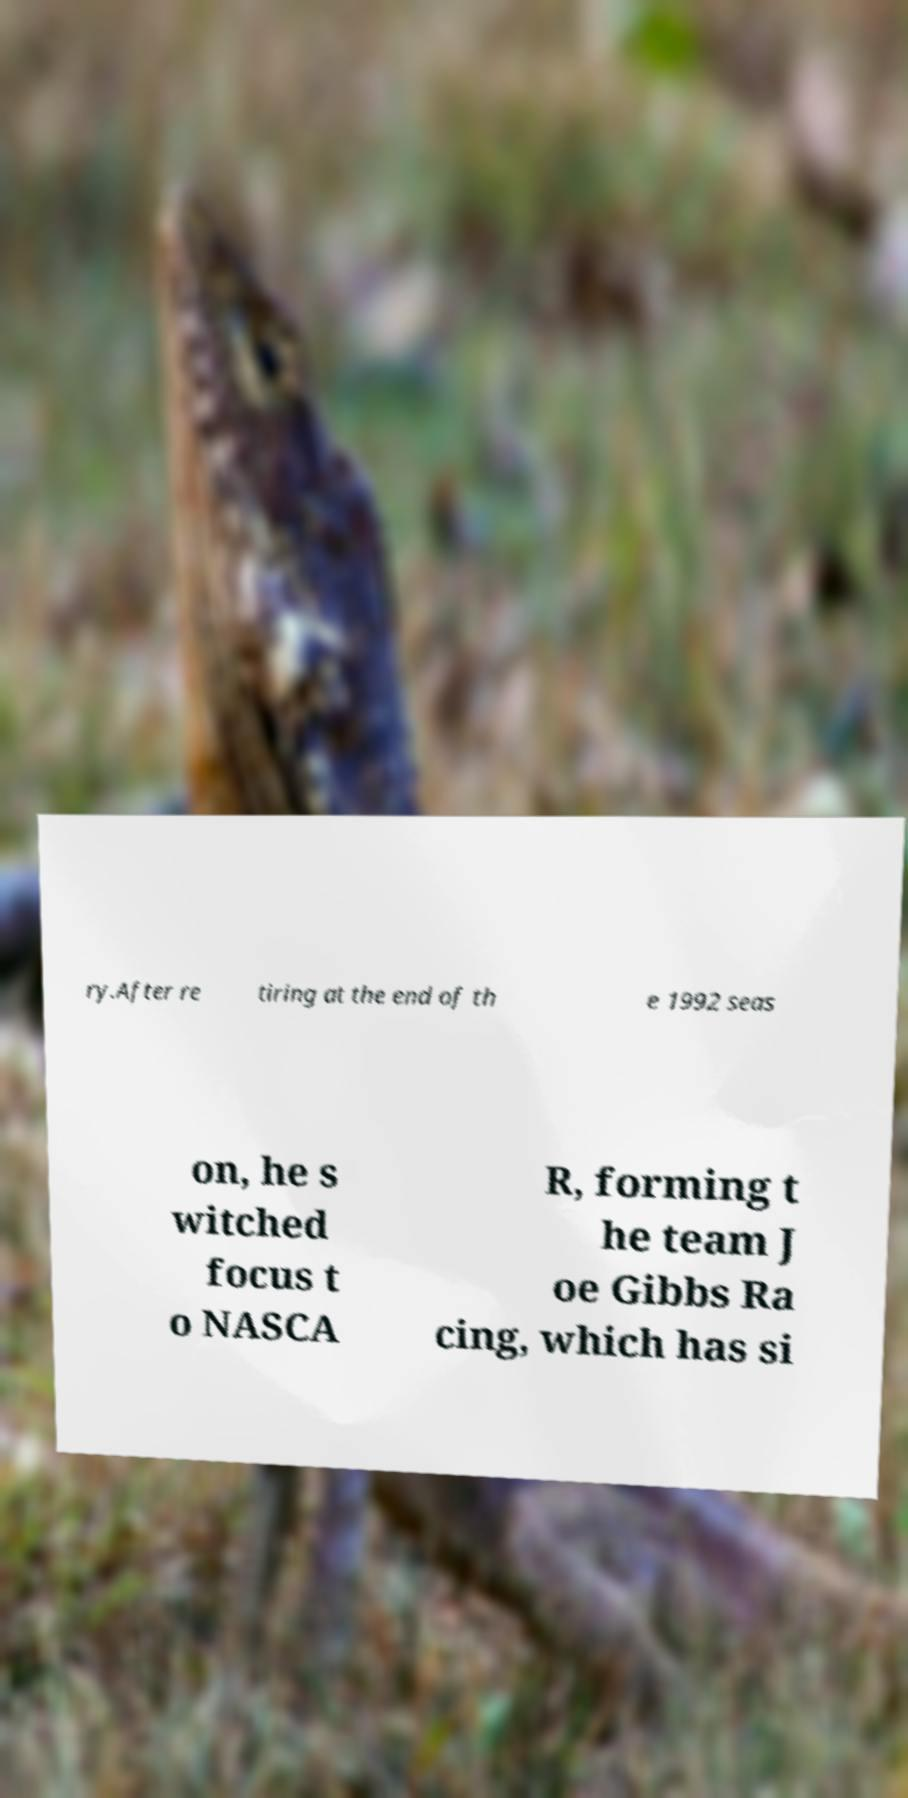Could you assist in decoding the text presented in this image and type it out clearly? ry.After re tiring at the end of th e 1992 seas on, he s witched focus t o NASCA R, forming t he team J oe Gibbs Ra cing, which has si 